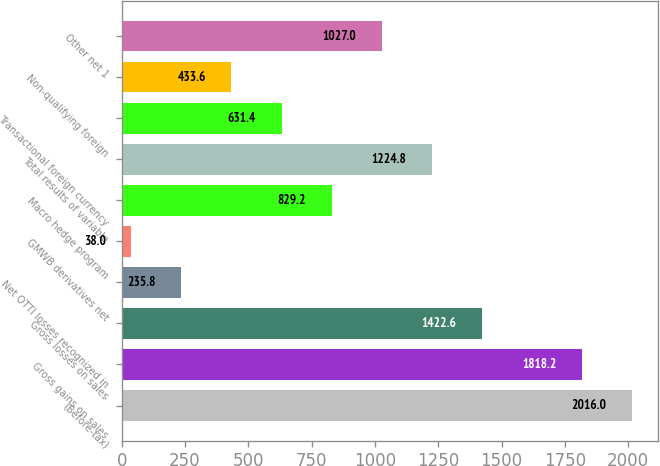<chart> <loc_0><loc_0><loc_500><loc_500><bar_chart><fcel>(Before-tax)<fcel>Gross gains on sales<fcel>Gross losses on sales<fcel>Net OTTI losses recognized in<fcel>GMWB derivatives net<fcel>Macro hedge program<fcel>Total results of variable<fcel>Transactional foreign currency<fcel>Non-qualifying foreign<fcel>Other net 1<nl><fcel>2016<fcel>1818.2<fcel>1422.6<fcel>235.8<fcel>38<fcel>829.2<fcel>1224.8<fcel>631.4<fcel>433.6<fcel>1027<nl></chart> 